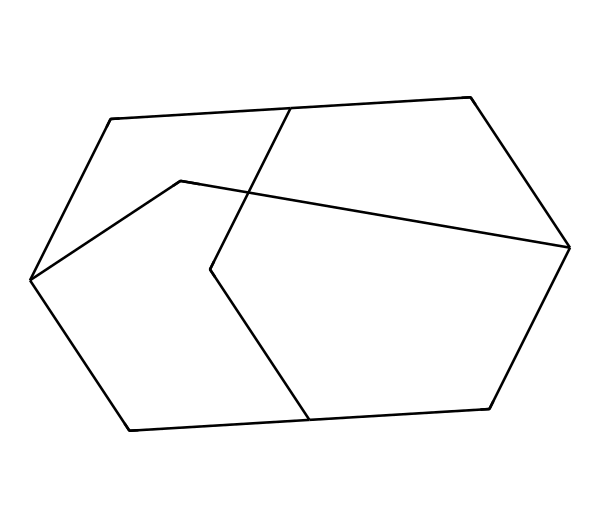What is the molecular formula of adamantane? To determine the molecular formula, count the number of carbon (C) and hydrogen (H) atoms in the structure. In the SMILES representation, we have 10 carbon atoms and 16 hydrogen atoms, leading to the formula C10H16.
Answer: C10H16 How many rings are present in adamantane? By analyzing the structure, we can see that adamantane consists of a fused three-ring system that forms a rigid structure. Hence, there are three rings in this cycloalkane.
Answer: 3 What is the degree of saturation of adamantane? The degree of saturation can be calculated based on the number of rings and double bonds present. Since adamantane has no double bonds and consists of rings, it is completely saturated with hydrogen atoms, giving it a degree of saturation of 10.
Answer: 10 Is adamantane chiral? To check for chirality, look for carbon atoms that are bonded to four different substituents. In the case of adamantane, all carbon atoms are part of the rigid cycloalkane structure with no such asymmetric centers.
Answer: No Which cycloalkane structure is adamantane derived from? Adamantane is derived from the structure of cyclohexane but forms a more complex arrangement involving multiple fused rings. This cycloalkane structure represents a unique case of a fused bicyclic system.
Answer: Cyclohexane What type of bonding predominates in adamantane? Given the structure, it is evident that the bonding primarily consists of single covalent bonds between carbon atoms, characteristic of aliphatic hydrocarbons, which also extends to the hydrogen atoms.
Answer: Single covalent bonds How does the rigidity of adamantane impact its use in antiviral drugs? The rigidity of adamantane comes from its three-dimensional structure, which influences its ability to fit into specific binding sites of viral proteins, enhancing its effectiveness as an antiviral agent by preventing viral replication.
Answer: Rigidity enhances binding 